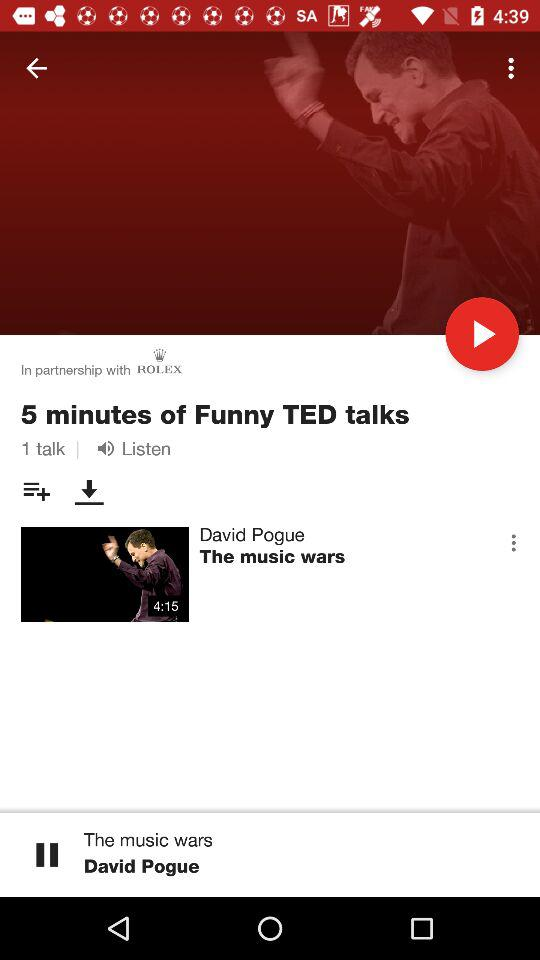Who is the singer of "The music wars"? The singer of "The music wars" is David Pogue. 